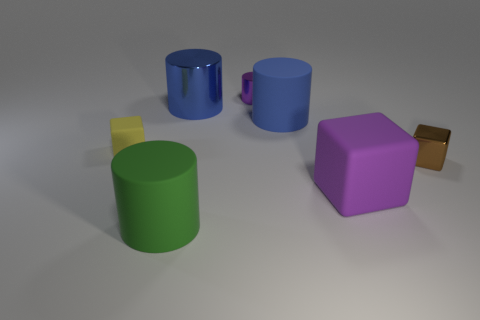There is another large thing that is the same color as the large metallic object; what is its material?
Offer a very short reply. Rubber. How many big objects are cyan spheres or green objects?
Your answer should be very brief. 1. Is the number of green cylinders less than the number of large green metallic objects?
Provide a short and direct response. No. The large object that is the same shape as the small matte object is what color?
Ensure brevity in your answer.  Purple. Is the number of rubber cylinders greater than the number of big purple objects?
Provide a short and direct response. Yes. What number of other things are the same material as the small yellow cube?
Your answer should be compact. 3. What shape is the rubber object that is on the left side of the large cylinder that is in front of the small cube that is behind the small brown thing?
Provide a succinct answer. Cube. Is the number of big green cylinders that are to the left of the green thing less than the number of blue shiny things that are in front of the small purple shiny cylinder?
Offer a very short reply. Yes. Is there a tiny object of the same color as the large rubber cube?
Ensure brevity in your answer.  Yes. Do the small purple cylinder and the big blue object to the right of the purple cylinder have the same material?
Give a very brief answer. No. 